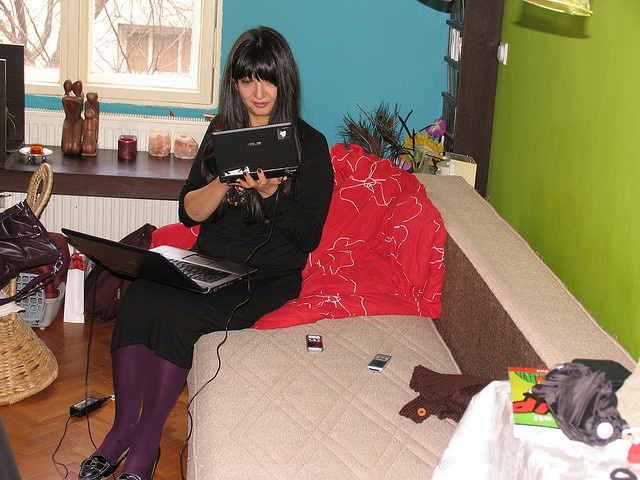Describe the objects in this image and their specific colors. I can see couch in darkgray and tan tones, people in darkgray, black, salmon, and gray tones, laptop in darkgray, black, gray, and lightgray tones, handbag in darkgray, black, maroon, and gray tones, and book in darkgray, lightgreen, salmon, khaki, and red tones in this image. 